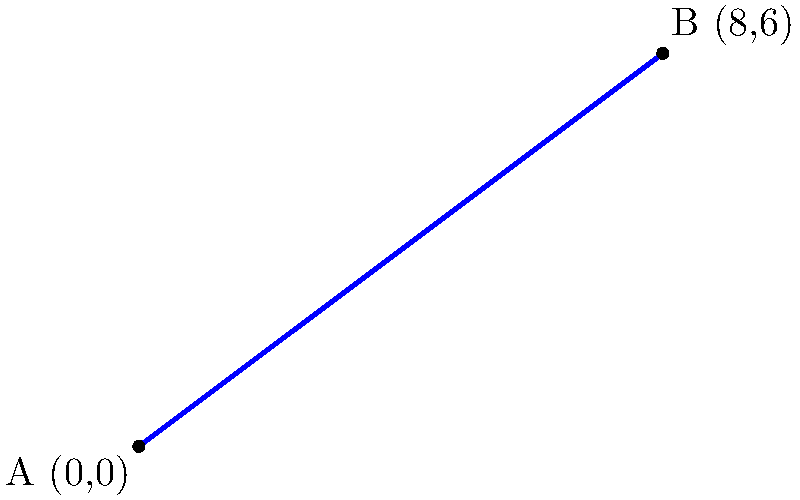A new public transit route is proposed to connect two underserved neighborhoods in a city. The route starts at point A (0,0) and ends at point B (8,6). Find the equation of the line representing this transit route in slope-intercept form $(y = mx + b)$. How would this route contribute to improving social equity in the city? To find the equation of the line in slope-intercept form $(y = mx + b)$, we need to follow these steps:

1. Calculate the slope $(m)$ of the line:
   $m = \frac{y_2 - y_1}{x_2 - x_1} = \frac{6 - 0}{8 - 0} = \frac{6}{8} = \frac{3}{4}$

2. Use the point-slope form of a line: $y - y_1 = m(x - x_1)$
   Let's use point A (0,0): $y - 0 = \frac{3}{4}(x - 0)$

3. Simplify the equation:
   $y = \frac{3}{4}x$

4. The y-intercept $(b)$ is 0, so our final equation in slope-intercept form is:
   $y = \frac{3}{4}x + 0$ or simply $y = \frac{3}{4}x$

This route would contribute to improving social equity in the city by:
- Connecting underserved neighborhoods, increasing access to opportunities
- Reducing transportation barriers for marginalized communities
- Promoting economic development along the transit corridor
- Decreasing reliance on private vehicles, benefiting lower-income residents
- Improving overall mobility and accessibility within the city
Answer: $y = \frac{3}{4}x$ 